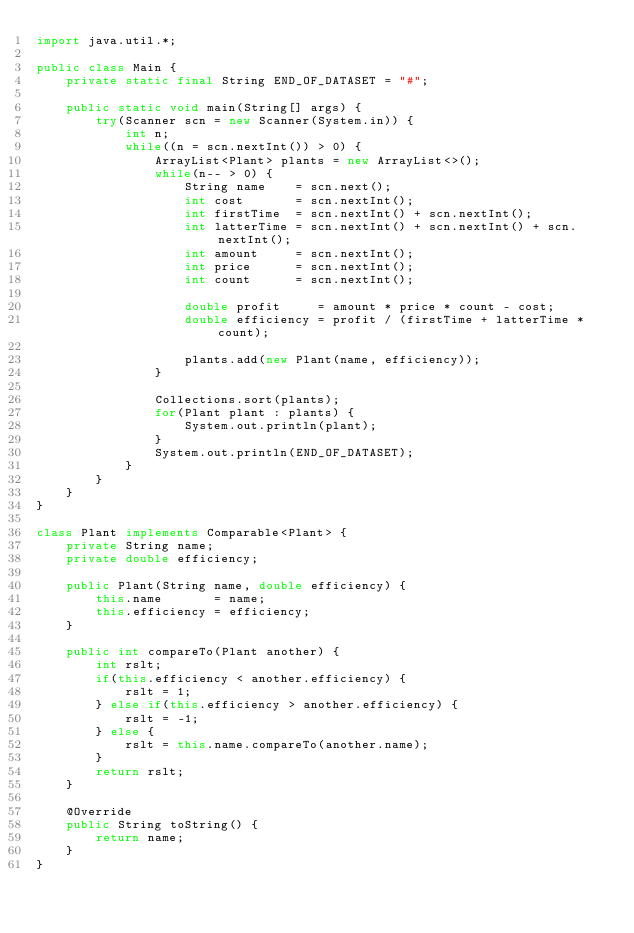<code> <loc_0><loc_0><loc_500><loc_500><_Java_>import java.util.*;

public class Main {
    private static final String END_OF_DATASET = "#";

    public static void main(String[] args) {
        try(Scanner scn = new Scanner(System.in)) {
            int n;
            while((n = scn.nextInt()) > 0) {
                ArrayList<Plant> plants = new ArrayList<>();
                while(n-- > 0) {
                    String name    = scn.next();
                    int cost       = scn.nextInt();
                    int firstTime  = scn.nextInt() + scn.nextInt();
                    int latterTime = scn.nextInt() + scn.nextInt() + scn.nextInt();
                    int amount     = scn.nextInt();
                    int price      = scn.nextInt();
                    int count      = scn.nextInt();

                    double profit     = amount * price * count - cost;
                    double efficiency = profit / (firstTime + latterTime * count);

                    plants.add(new Plant(name, efficiency));
                }

                Collections.sort(plants);
                for(Plant plant : plants) {
                    System.out.println(plant);
                }
                System.out.println(END_OF_DATASET);
            }
        }
    }
}

class Plant implements Comparable<Plant> {
    private String name;
    private double efficiency;

    public Plant(String name, double efficiency) {
        this.name       = name;
        this.efficiency = efficiency;
    }

    public int compareTo(Plant another) {
        int rslt;
        if(this.efficiency < another.efficiency) {
            rslt = 1;
        } else if(this.efficiency > another.efficiency) {
            rslt = -1;
        } else {
            rslt = this.name.compareTo(another.name);
        }
        return rslt;
    }

    @Override
    public String toString() {
        return name;
    }
}</code> 